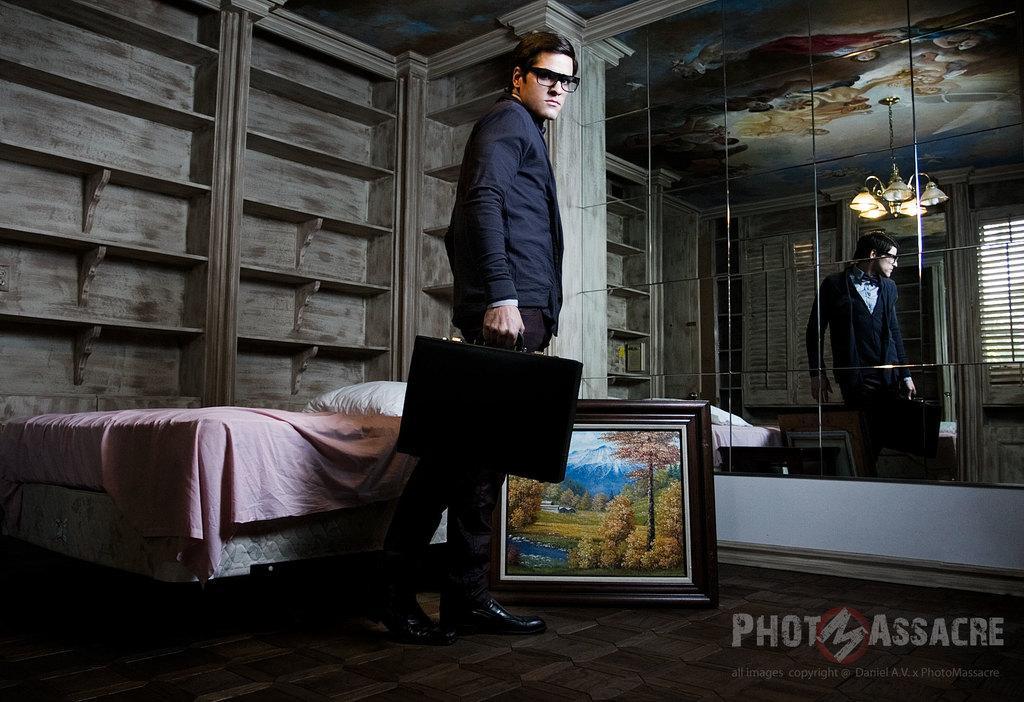How would you summarize this image in a sentence or two? In this image I can see a person is standing on the floor and is holding a suitcase in hand, logo, wall painting, bed and a cushion. In the background I can see cupboards, mirror, window blind, chairs and a rooftop. This image is taken may be in a hall. 